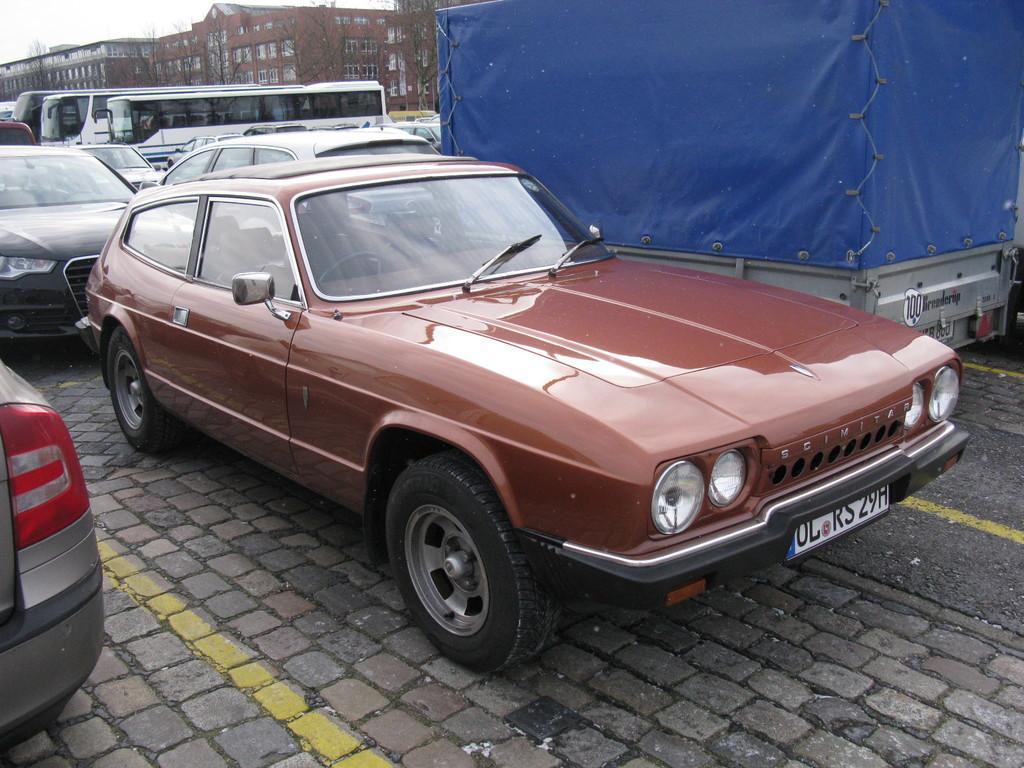Describe this image in one or two sentences. In this picture we can see maroon car, beside that there is a truck. In the background we can see many bus which is parked near to the trees. At the top we can see the buildings. In the top left corner there is a sky. 